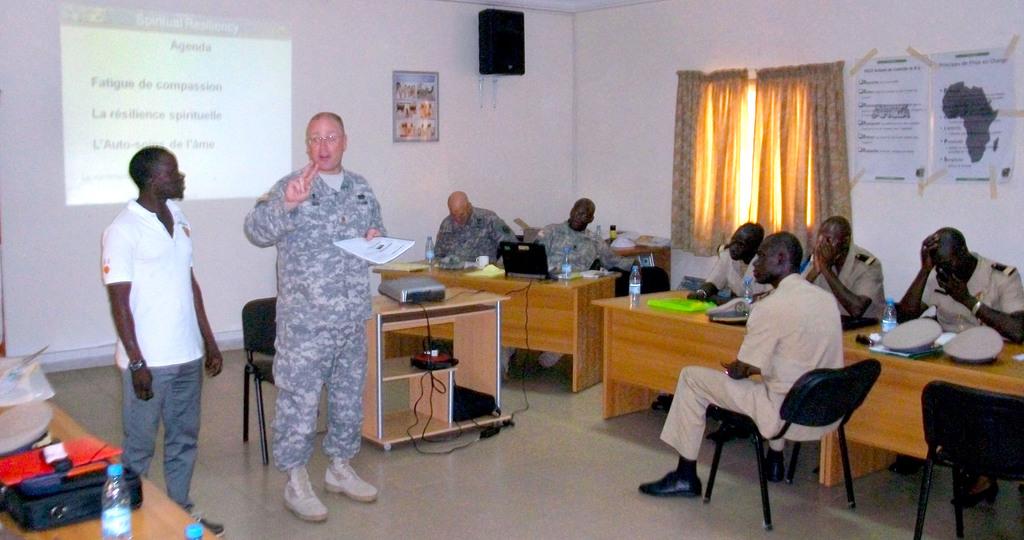What is projected on the wall?
Your answer should be compact. Agenda. 